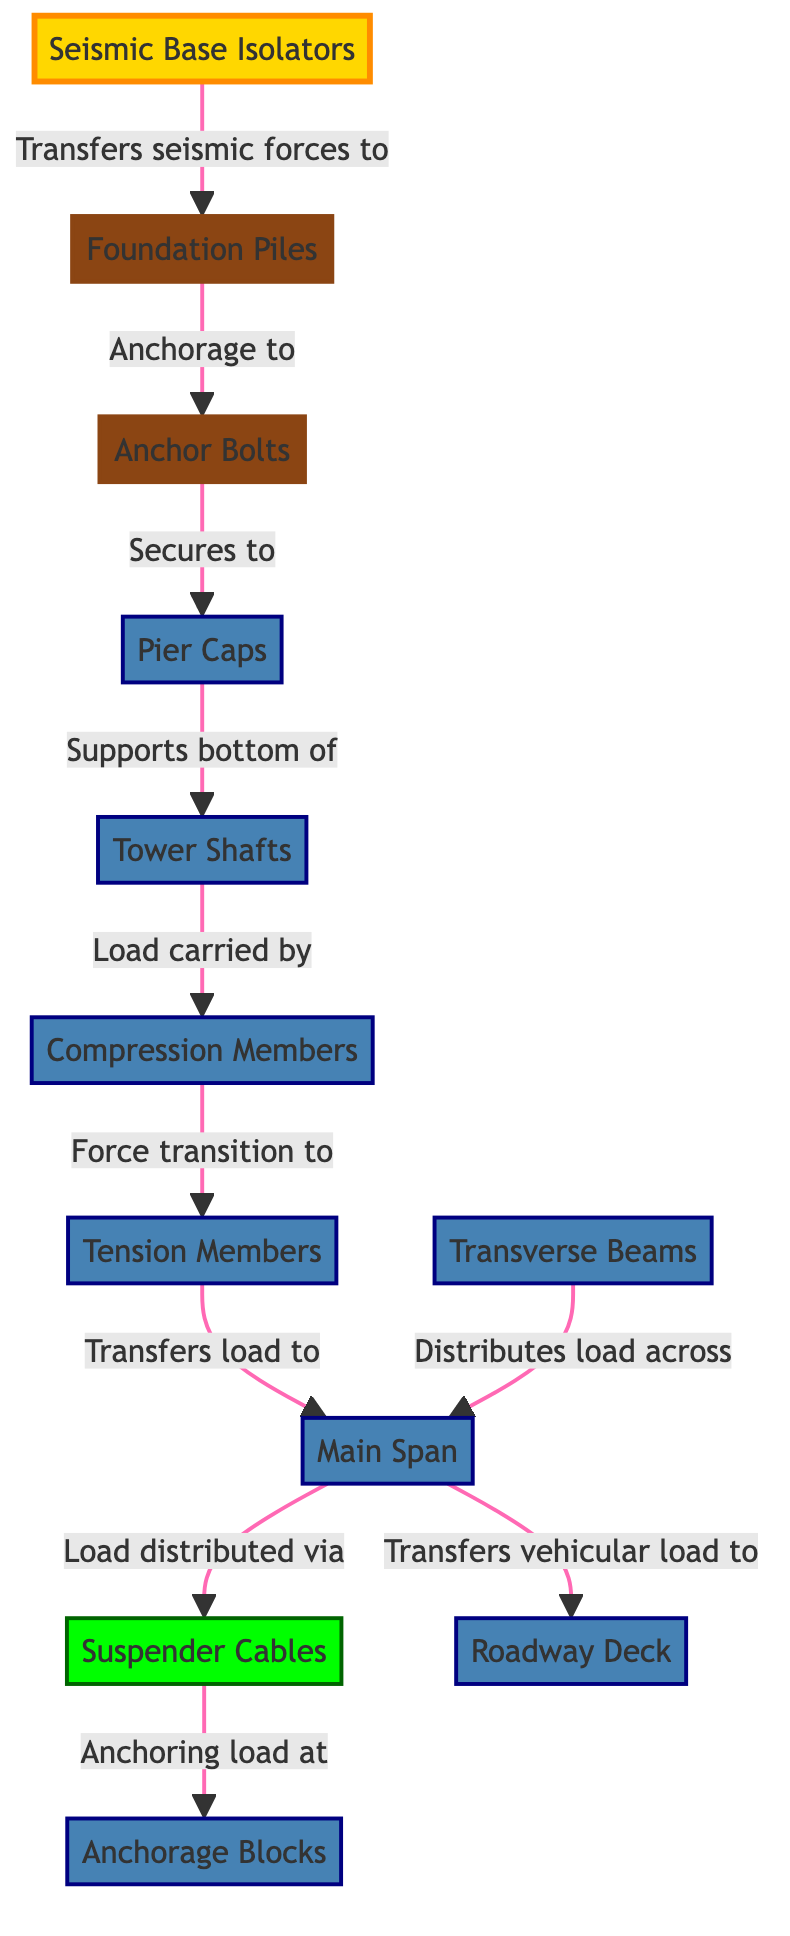What is the first node in the load pathway? The first node shown in the diagram is "Seismic Base Isolators," which is responsible for starting the load transfer in the seismic load path.
Answer: Seismic Base Isolators How many main nodes are in the diagram? Counting each of the nodes listed in the diagram data, there are a total of 12 main nodes representing different structural components.
Answer: 12 What does "Anchor Bolts" secure to? According to the diagram, "Anchor Bolts" secures to "Pier Caps," linking these two components in the load pathway.
Answer: Pier Caps Which component carries the load from "Tower Shafts"? The "Tower Shafts" carry loads that are transitioned to the "Compression Members," indicating that these members are essential for structural load support beneath the towers.
Answer: Compression Members What is the role of "Suspender Cables" in the load distribution? "Suspender Cables" distribute the load from the "Main Span" to the "Anchorage Blocks," anchoring the load at both ends of the suspension system.
Answer: Anchoring load at Anchorage Blocks Describe the connection from "Transverse Beams" to "Main Span." The connection indicates that "Transverse Beams" distribute the load across the "Main Span," enabling even load distribution throughout the bridge structure.
Answer: Distributes load across Main Span How do "Compression Members" and "Tension Members" interact? "Compression Members" transition force to "Tension Members," indicating a critical interaction where compressive forces are shifted to tensile forces within the structure.
Answer: Force transition to Tension Members What is the final load transfer in the diagram? The final load transfer depicted is from the "Main Span" to the "Roadway Deck," conveying the vehicular load that the bridge supports.
Answer: Transfers vehicular load to Roadway Deck Which component directly connects to "Foundation Piles"? "Seismic Base Isolators" directly connect to the "Foundation Piles," indicating that seismic forces are first transferred to these foundational elements.
Answer: Foundation Piles What visual representation does the dashed line suggest in the diagram? In the diagram, the dashed line represents the flow of forces from one structural element to another, clarifying the load path within the entire structural system.
Answer: Flow of forces 